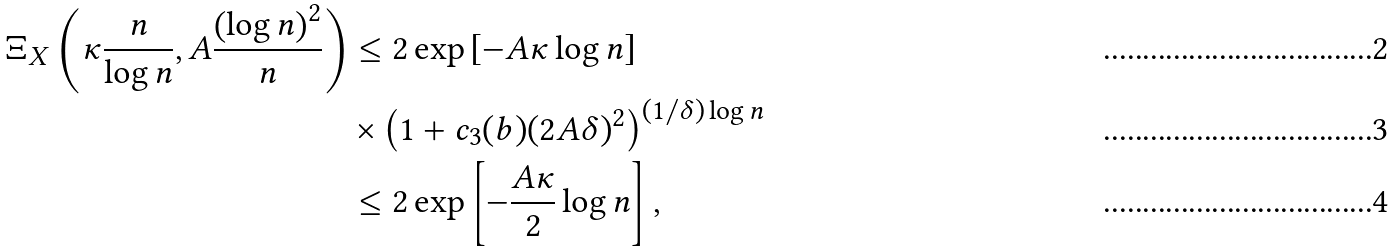<formula> <loc_0><loc_0><loc_500><loc_500>\Xi _ { X } \left ( \kappa \frac { n } { \log n } , A \frac { \left ( \log n \right ) ^ { 2 } } { n } \right ) & \leq 2 \exp \left [ - A \kappa \log n \right ] \\ & \times \left ( 1 + c _ { 3 } ( b ) ( 2 A \delta ) ^ { 2 } \right ) ^ { ( 1 / \delta ) \log n } \\ & \leq 2 \exp \left [ - \frac { A \kappa } { 2 } \log n \right ] ,</formula> 